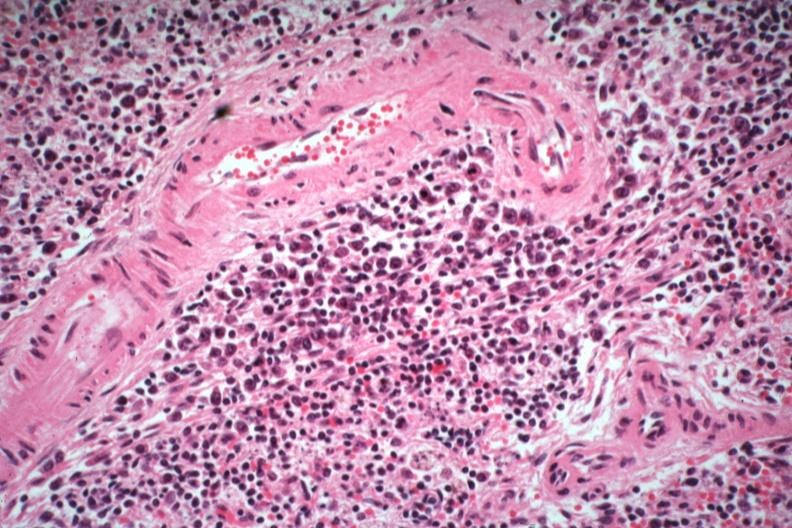what is present?
Answer the question using a single word or phrase. Hematologic 